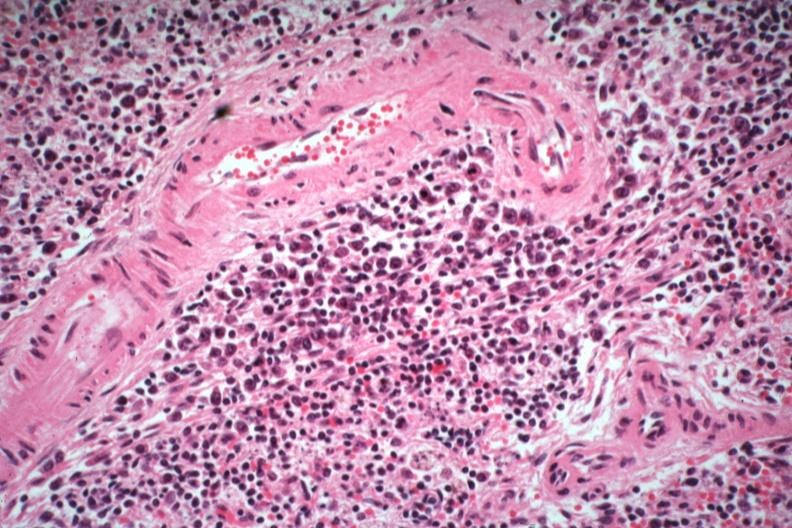what is present?
Answer the question using a single word or phrase. Hematologic 